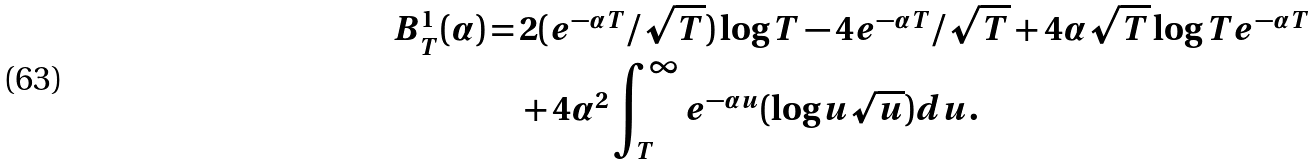<formula> <loc_0><loc_0><loc_500><loc_500>B _ { T } ^ { 1 } ( \alpha ) = & \, 2 ( e ^ { - \alpha T } / \sqrt { T } ) \log T - 4 e ^ { - \alpha T } / \sqrt { T } + 4 \alpha \sqrt { T } \log T e ^ { - \alpha T } \\ & \, + 4 \alpha ^ { 2 } \int _ { T } ^ { \infty } e ^ { - \alpha u } ( \log u \sqrt { u } ) d u . \\</formula> 